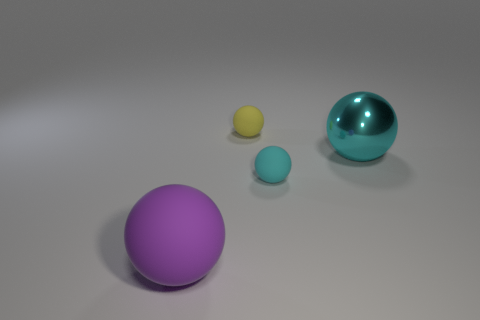Can you describe the lighting and shadow effects in the scene? The scene is illuminated by a soft overhead light source that casts gentle shadows beneath each spherical object. The shadows vary in length and darkness corresponding to the sizes and distances of the spheres from the light source, which contributes to the depth and realism of the image. 